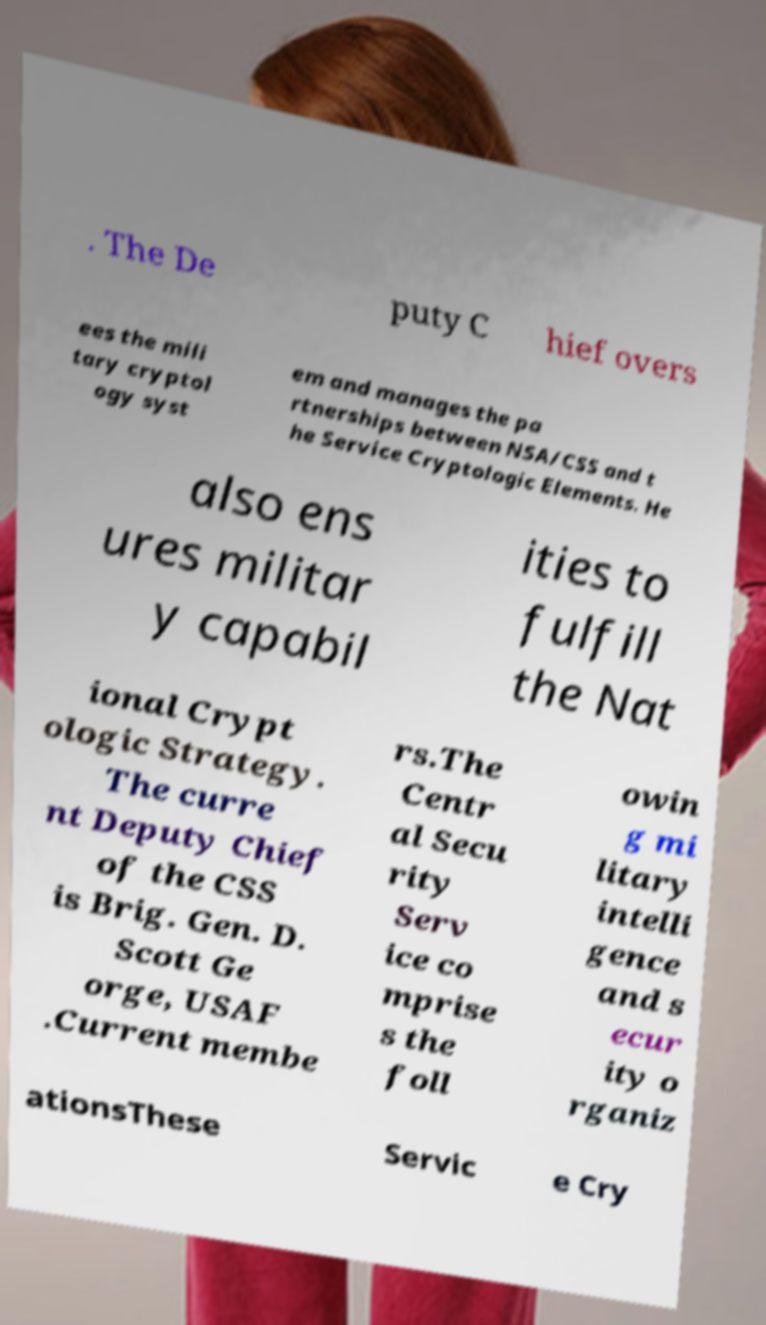Can you accurately transcribe the text from the provided image for me? . The De puty C hief overs ees the mili tary cryptol ogy syst em and manages the pa rtnerships between NSA/CSS and t he Service Cryptologic Elements. He also ens ures militar y capabil ities to fulfill the Nat ional Crypt ologic Strategy. The curre nt Deputy Chief of the CSS is Brig. Gen. D. Scott Ge orge, USAF .Current membe rs.The Centr al Secu rity Serv ice co mprise s the foll owin g mi litary intelli gence and s ecur ity o rganiz ationsThese Servic e Cry 